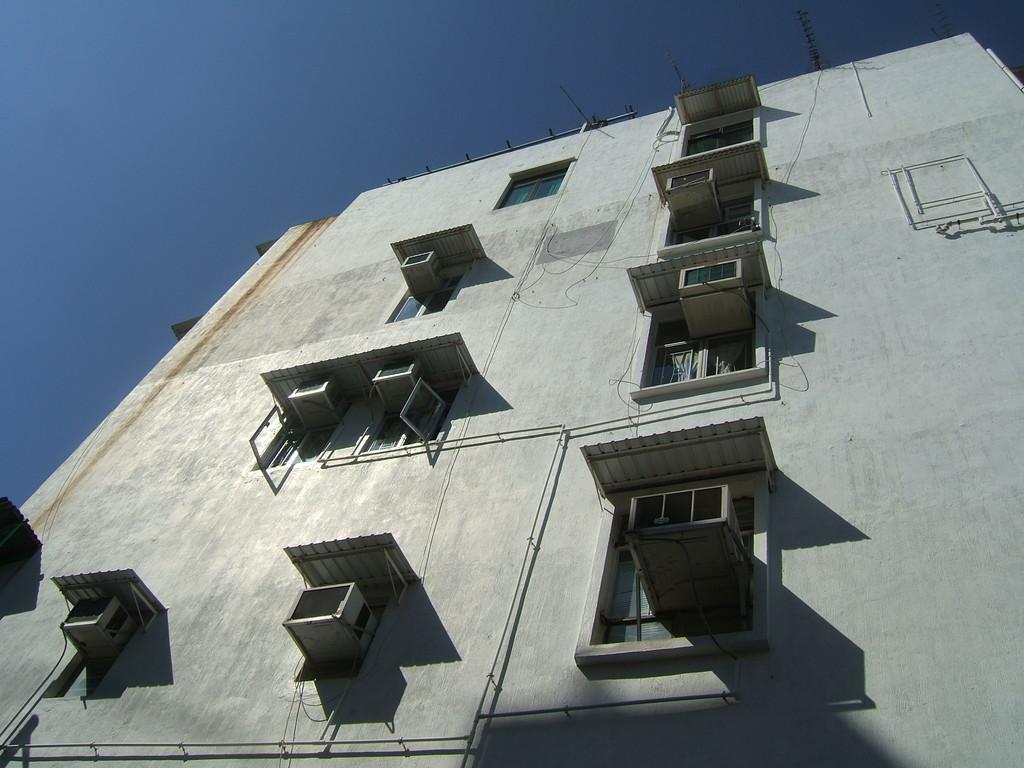Could you give a brief overview of what you see in this image? In this image I can see white colour building, the sky and few windows. 